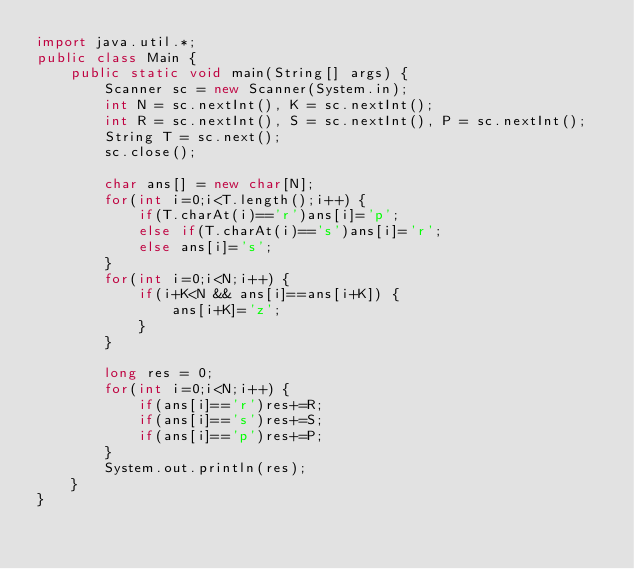Convert code to text. <code><loc_0><loc_0><loc_500><loc_500><_Java_>import java.util.*;
public class Main {
	public static void main(String[] args) {
		Scanner sc = new Scanner(System.in);
		int N = sc.nextInt(), K = sc.nextInt();
		int R = sc.nextInt(), S = sc.nextInt(), P = sc.nextInt();
		String T = sc.next(); 
		sc.close();
		
		char ans[] = new char[N];
		for(int i=0;i<T.length();i++) {
			if(T.charAt(i)=='r')ans[i]='p';
			else if(T.charAt(i)=='s')ans[i]='r';
			else ans[i]='s';
		}
		for(int i=0;i<N;i++) {
			if(i+K<N && ans[i]==ans[i+K]) {
				ans[i+K]='z';
			}
		}
		
		long res = 0;
		for(int i=0;i<N;i++) {
			if(ans[i]=='r')res+=R;
			if(ans[i]=='s')res+=S;
			if(ans[i]=='p')res+=P;
		}
		System.out.println(res);
	}
}
</code> 